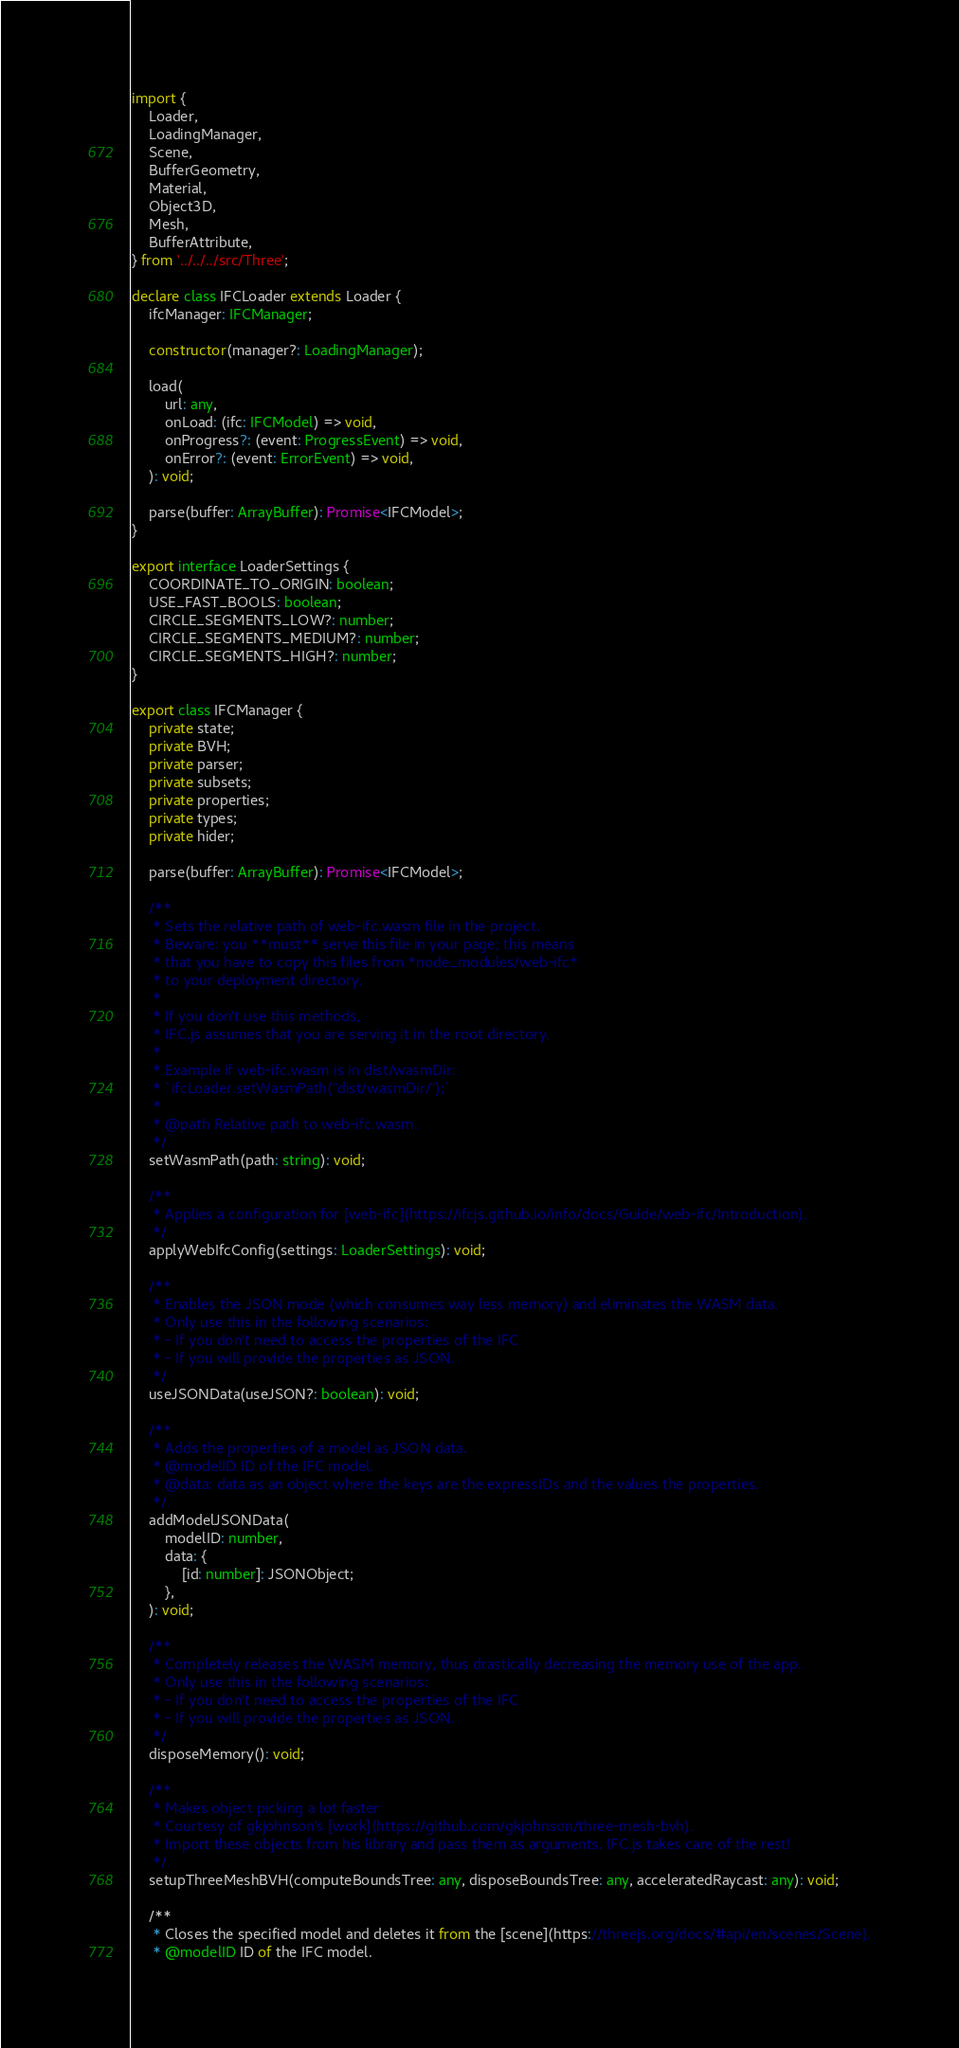<code> <loc_0><loc_0><loc_500><loc_500><_TypeScript_>import {
    Loader,
    LoadingManager,
    Scene,
    BufferGeometry,
    Material,
    Object3D,
    Mesh,
    BufferAttribute,
} from '../../../src/Three';

declare class IFCLoader extends Loader {
    ifcManager: IFCManager;

    constructor(manager?: LoadingManager);

    load(
        url: any,
        onLoad: (ifc: IFCModel) => void,
        onProgress?: (event: ProgressEvent) => void,
        onError?: (event: ErrorEvent) => void,
    ): void;

    parse(buffer: ArrayBuffer): Promise<IFCModel>;
}

export interface LoaderSettings {
    COORDINATE_TO_ORIGIN: boolean;
    USE_FAST_BOOLS: boolean;
    CIRCLE_SEGMENTS_LOW?: number;
    CIRCLE_SEGMENTS_MEDIUM?: number;
    CIRCLE_SEGMENTS_HIGH?: number;
}

export class IFCManager {
    private state;
    private BVH;
    private parser;
    private subsets;
    private properties;
    private types;
    private hider;

    parse(buffer: ArrayBuffer): Promise<IFCModel>;

    /**
     * Sets the relative path of web-ifc.wasm file in the project.
     * Beware: you **must** serve this file in your page; this means
     * that you have to copy this files from *node_modules/web-ifc*
     * to your deployment directory.
     *
     * If you don't use this methods,
     * IFC.js assumes that you are serving it in the root directory.
     *
     * Example if web-ifc.wasm is in dist/wasmDir:
     * `ifcLoader.setWasmPath("dist/wasmDir/");`
     *
     * @path Relative path to web-ifc.wasm.
     */
    setWasmPath(path: string): void;

    /**
     * Applies a configuration for [web-ifc](https://ifcjs.github.io/info/docs/Guide/web-ifc/Introduction).
     */
    applyWebIfcConfig(settings: LoaderSettings): void;

    /**
     * Enables the JSON mode (which consumes way less memory) and eliminates the WASM data.
     * Only use this in the following scenarios:
     * - If you don't need to access the properties of the IFC
     * - If you will provide the properties as JSON.
     */
    useJSONData(useJSON?: boolean): void;

    /**
     * Adds the properties of a model as JSON data.
     * @modelID ID of the IFC model.
     * @data: data as an object where the keys are the expressIDs and the values the properties.
     */
    addModelJSONData(
        modelID: number,
        data: {
            [id: number]: JSONObject;
        },
    ): void;

    /**
     * Completely releases the WASM memory, thus drastically decreasing the memory use of the app.
     * Only use this in the following scenarios:
     * - If you don't need to access the properties of the IFC
     * - If you will provide the properties as JSON.
     */
    disposeMemory(): void;

    /**
     * Makes object picking a lot faster
     * Courtesy of gkjohnson's [work](https://github.com/gkjohnson/three-mesh-bvh).
     * Import these objects from his library and pass them as arguments. IFC.js takes care of the rest!
     */
    setupThreeMeshBVH(computeBoundsTree: any, disposeBoundsTree: any, acceleratedRaycast: any): void;

    /**
     * Closes the specified model and deletes it from the [scene](https://threejs.org/docs/#api/en/scenes/Scene).
     * @modelID ID of the IFC model.</code> 